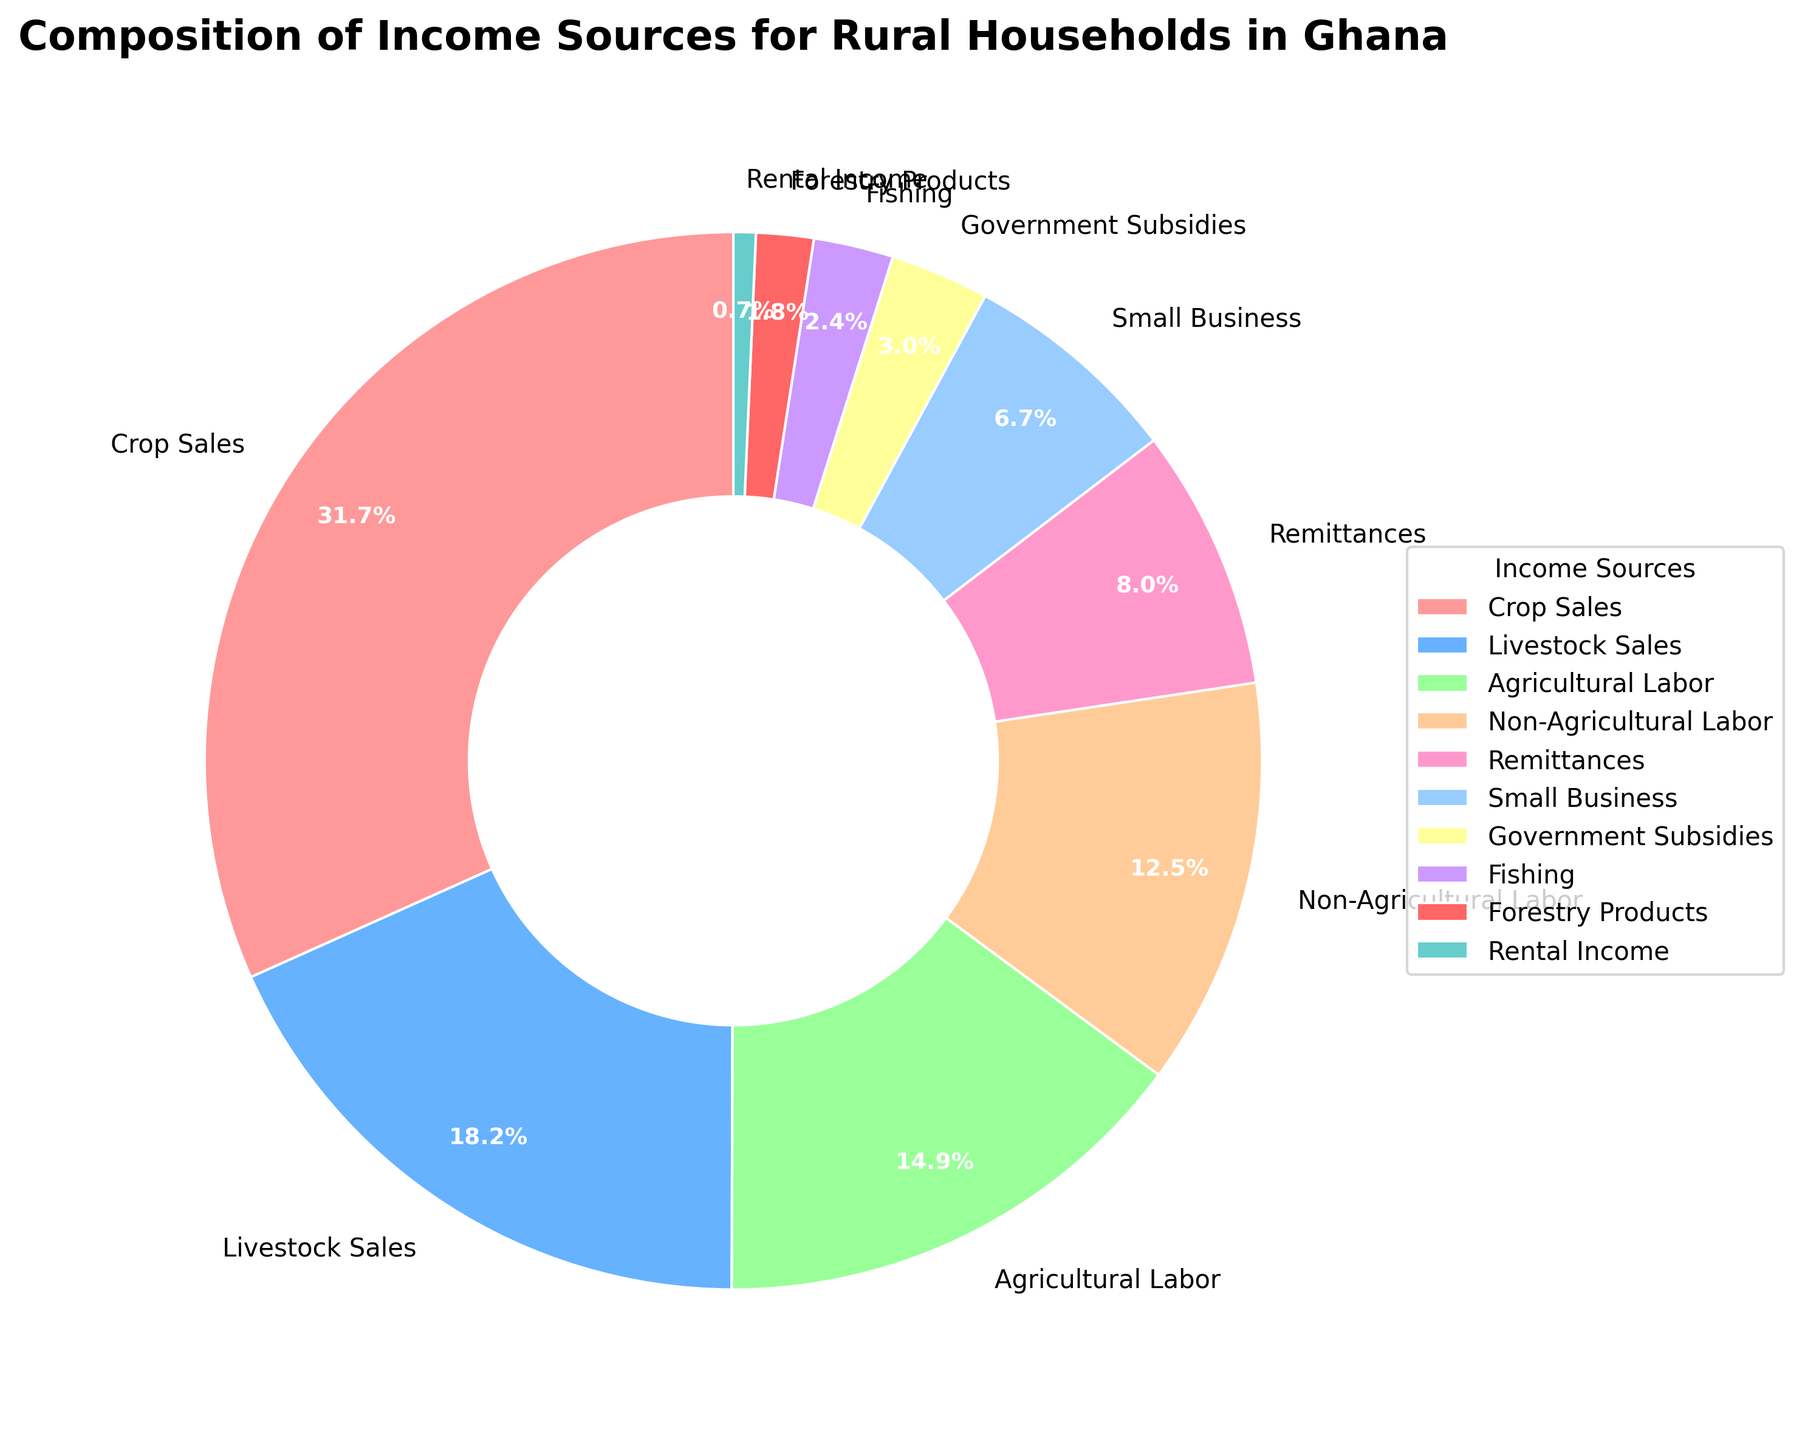What is the largest income source for rural households in Ghana? According to the pie chart, the largest income source is represented by the largest wedge. Crop Sales occupies the largest portion of the pie chart.
Answer: Crop Sales How much larger is the contribution of Crop Sales compared to Remittances? Crop Sales contributes 32.5% while Remittances contribute 8.2%. The difference is calculated as 32.5% - 8.2% = 24.3%.
Answer: 24.3% Which income source has a smaller percentage than Government Subsidies but larger than Forestry Products? Government Subsidies contribute 3.1% and Forestry Products contribute 1.8%. The source that falls in between these two percentages is Fishing at 2.5%.
Answer: Fishing What is the combined percentage of income from Agricultural Labor and Non-Agricultural Labor? Agricultural Labor is 15.3% and Non-Agricultural Labor is 12.8%. Adding these gives 15.3% + 12.8% = 28.1%.
Answer: 28.1% Is the percentage contribution of Livestock Sales greater than that of Small Business? Livestock Sales contribute 18.7% while Small Business contributes 6.9%. Since 18.7% > 6.9%, Livestock Sales has a greater contribution.
Answer: Yes What is the difference between the percentages of Non-Agricultural Labor and Agricultural Labor? Agricultural Labor is 15.3% while Non-Agricultural Labor is 12.8%. The difference is calculated as 15.3% - 12.8% = 2.5%.
Answer: 2.5% Which source contributes the least to the household income? The smallest wedge in the pie chart indicates the smallest contribution, which is Rental Income at 0.7%.
Answer: Rental Income What is the combined income contribution of Crop Sales, Livestock Sales, and Agricultural Labor? Crop Sales contribute 32.5%, Livestock Sales contribute 18.7%, and Agricultural Labor contributes 15.3%. Adding these gives 32.5% + 18.7% + 15.3% = 66.5%.
Answer: 66.5% Which income source contributes just under 15% to the total income? The pie chart shows Agricultural Labor at 15.3% and Non-Agricultural Labor just below it at 12.8%. Therefore, Non-Agricultural Labor contributes just under 15%.
Answer: Non-Agricultural Labor 